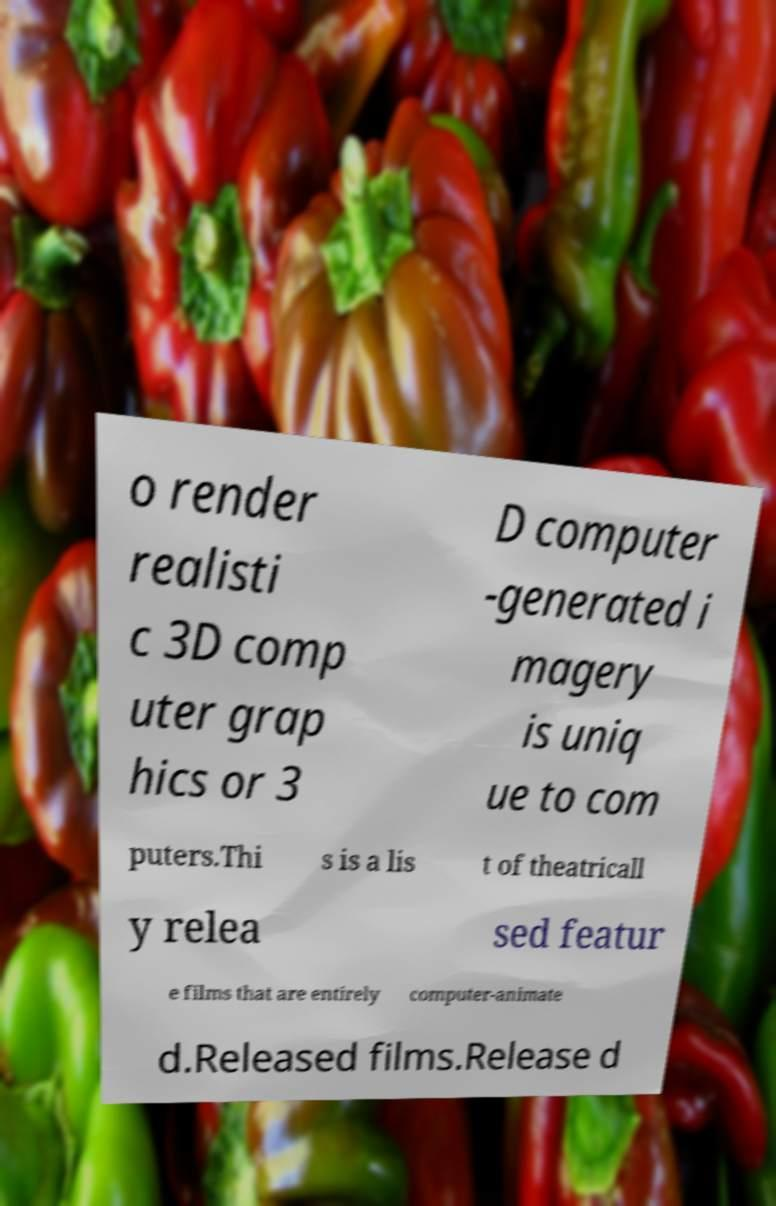Could you assist in decoding the text presented in this image and type it out clearly? o render realisti c 3D comp uter grap hics or 3 D computer -generated i magery is uniq ue to com puters.Thi s is a lis t of theatricall y relea sed featur e films that are entirely computer-animate d.Released films.Release d 